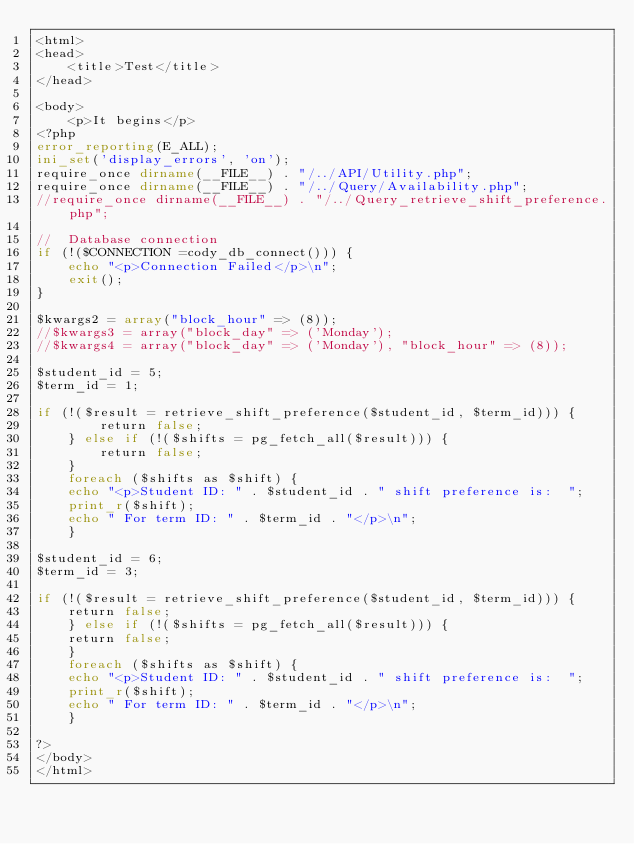<code> <loc_0><loc_0><loc_500><loc_500><_PHP_><html>
<head>
    <title>Test</title>
</head>

<body>
    <p>It begins</p>
<?php
error_reporting(E_ALL);
ini_set('display_errors', 'on');
require_once dirname(__FILE__) . "/../API/Utility.php";
require_once dirname(__FILE__) . "/../Query/Availability.php";
//require_once dirname(__FILE__) . "/../Query_retrieve_shift_preference.php";

//  Database connection
if (!($CONNECTION =cody_db_connect())) {
    echo "<p>Connection Failed</p>\n";
    exit();
}

$kwargs2 = array("block_hour" => (8));
//$kwargs3 = array("block_day" => ('Monday');
//$kwargs4 = array("block_day" => ('Monday'), "block_hour" => (8));

$student_id = 5;
$term_id = 1;

if (!($result = retrieve_shift_preference($student_id, $term_id))) {
        return false;
    } else if (!($shifts = pg_fetch_all($result))) {
        return false;
    }
    foreach ($shifts as $shift) {
	echo "<p>Student ID: " . $student_id . " shift preference is:  ";
	print_r($shift);
	echo " For term ID: " . $term_id . "</p>\n";
    }

$student_id = 6;
$term_id = 3;

if (!($result = retrieve_shift_preference($student_id, $term_id))) {
    return false;
    } else if (!($shifts = pg_fetch_all($result))) {
	return false;
    }
    foreach ($shifts as $shift) {
    echo "<p>Student ID: " . $student_id . " shift preference is:  ";
    print_r($shift);
    echo " For term ID: " . $term_id . "</p>\n";
    }   
			
?>
</body>
</html>
</code> 